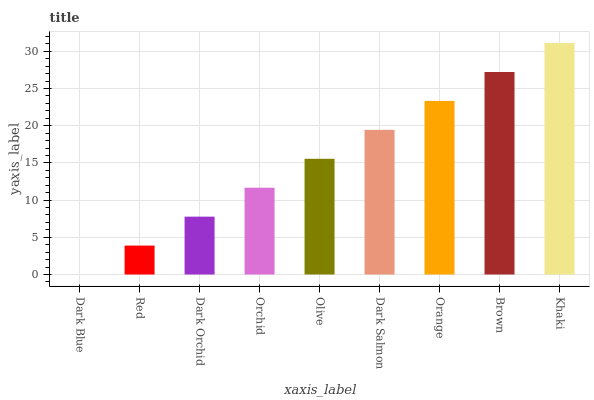Is Dark Blue the minimum?
Answer yes or no. Yes. Is Khaki the maximum?
Answer yes or no. Yes. Is Red the minimum?
Answer yes or no. No. Is Red the maximum?
Answer yes or no. No. Is Red greater than Dark Blue?
Answer yes or no. Yes. Is Dark Blue less than Red?
Answer yes or no. Yes. Is Dark Blue greater than Red?
Answer yes or no. No. Is Red less than Dark Blue?
Answer yes or no. No. Is Olive the high median?
Answer yes or no. Yes. Is Olive the low median?
Answer yes or no. Yes. Is Dark Orchid the high median?
Answer yes or no. No. Is Dark Blue the low median?
Answer yes or no. No. 